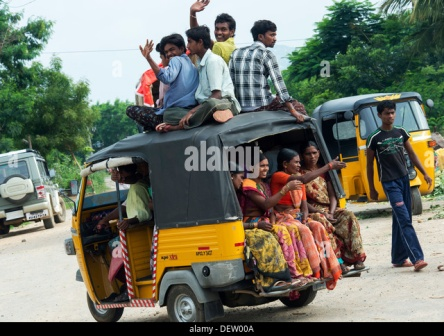Let’s dive into the mind of the person sitting on top of the rickshaw, and imagine what they might be thinking. As the rickshaw trundles along the road, Arjun feels the wind rushing past him, tickling his face. He's perched atop the rickshaw, and below him, he can see his friends, their gleeful faces turned skyward. 'What a day this has been,' he muses, a grin spreading across his face. The world looks different from up here—more vivid, more alive. He feels a camaraderie, a unity with his buddies that he seldom feels during regular school days. The worries of exams, the pressures of daily life—they all seem miles away. At this moment, there's just the open road, the rustling leaves, and the sound of laughter mingling with the hum of the engine. 'I wish we could freeze this moment,' he thinks, hoping this joyous ride never has to end. 